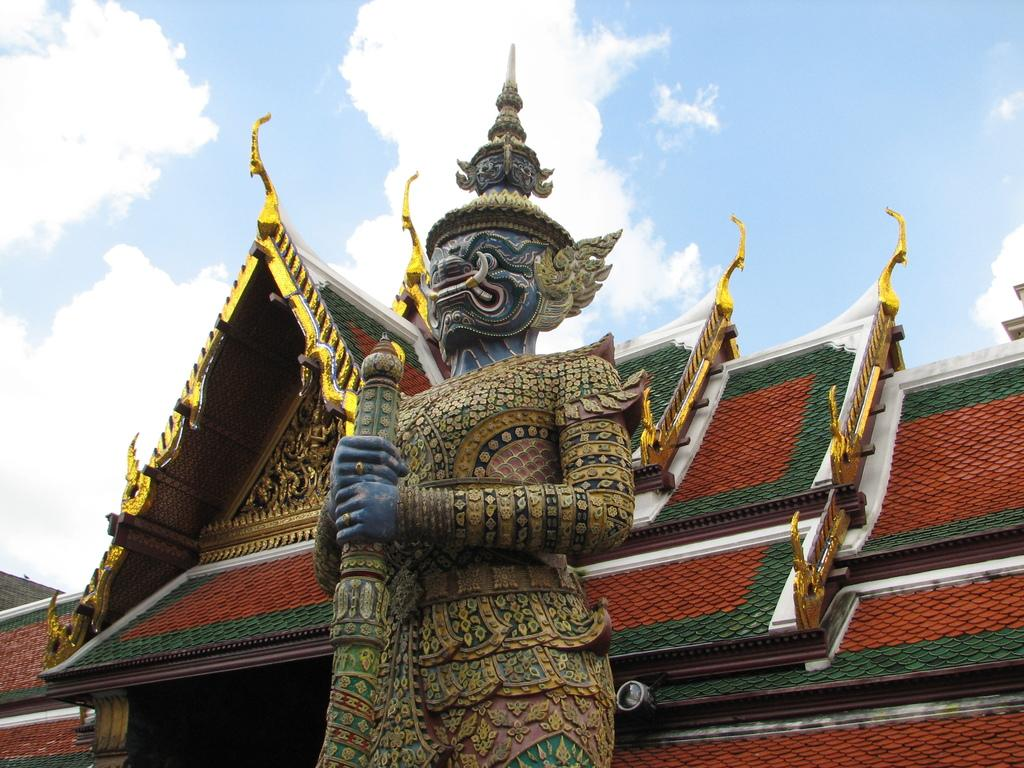What is the main subject in the image? There is a statue in the image. What can be seen in the background of the image? There are roofs and clouds visible in the background of the image. How many bears are sitting on the statue in the image? There are no bears present in the image. What type of clocks can be seen hanging from the clouds in the image? There are no clocks visible in the image, and the clouds are not holding any objects. 